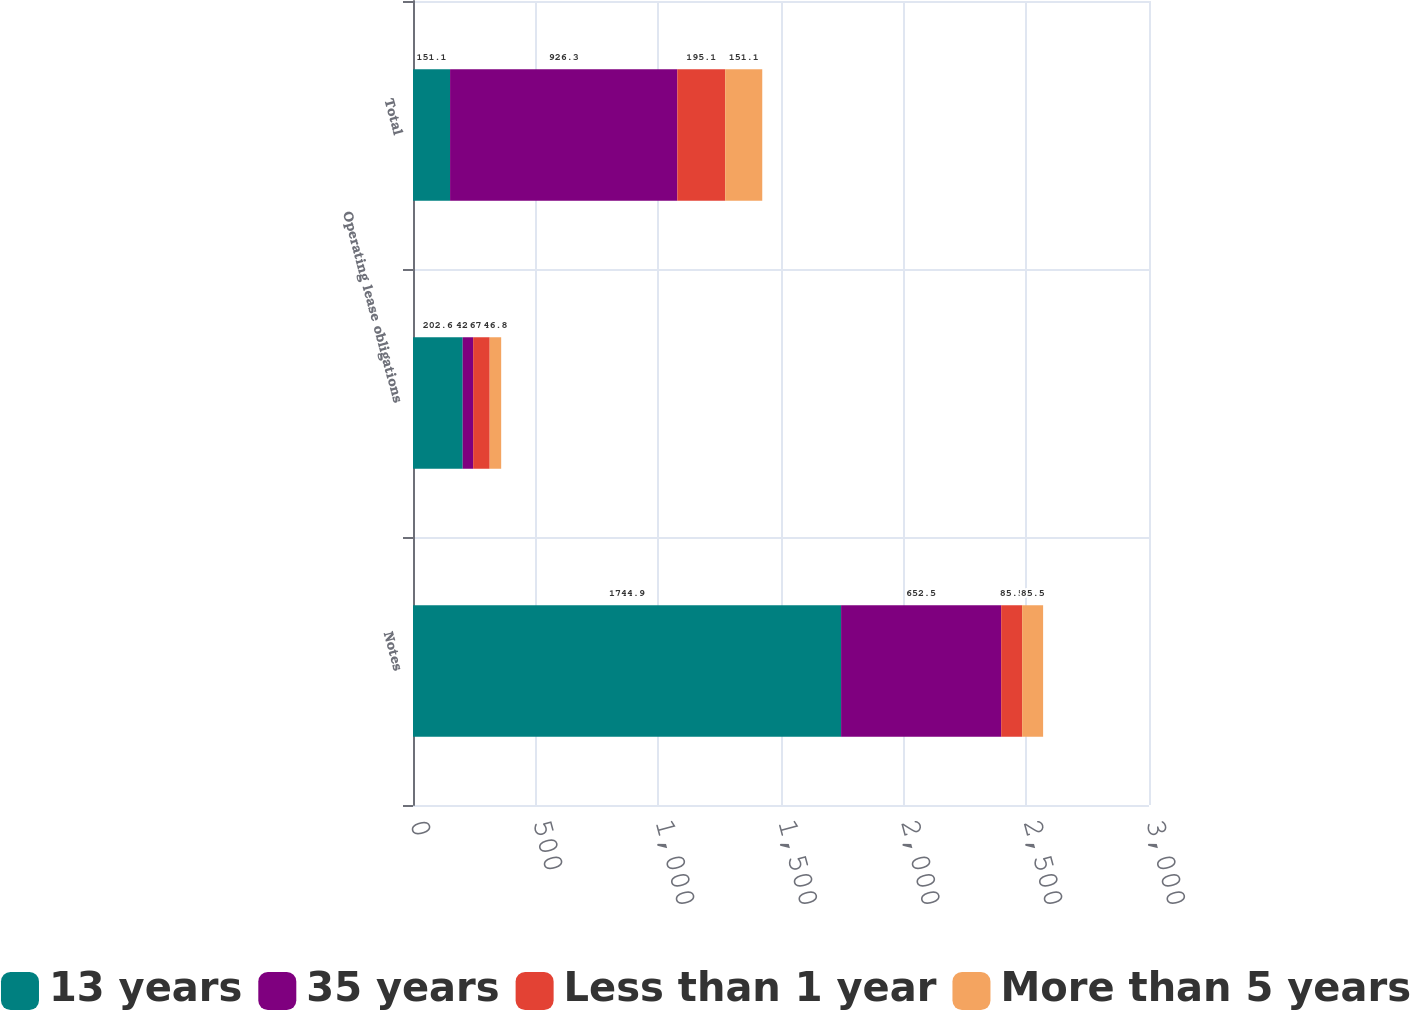Convert chart. <chart><loc_0><loc_0><loc_500><loc_500><stacked_bar_chart><ecel><fcel>Notes<fcel>Operating lease obligations<fcel>Total<nl><fcel>13 years<fcel>1744.9<fcel>202.6<fcel>151.1<nl><fcel>35 years<fcel>652.5<fcel>42.6<fcel>926.3<nl><fcel>Less than 1 year<fcel>85.5<fcel>67.4<fcel>195.1<nl><fcel>More than 5 years<fcel>85.5<fcel>46.8<fcel>151.1<nl></chart> 